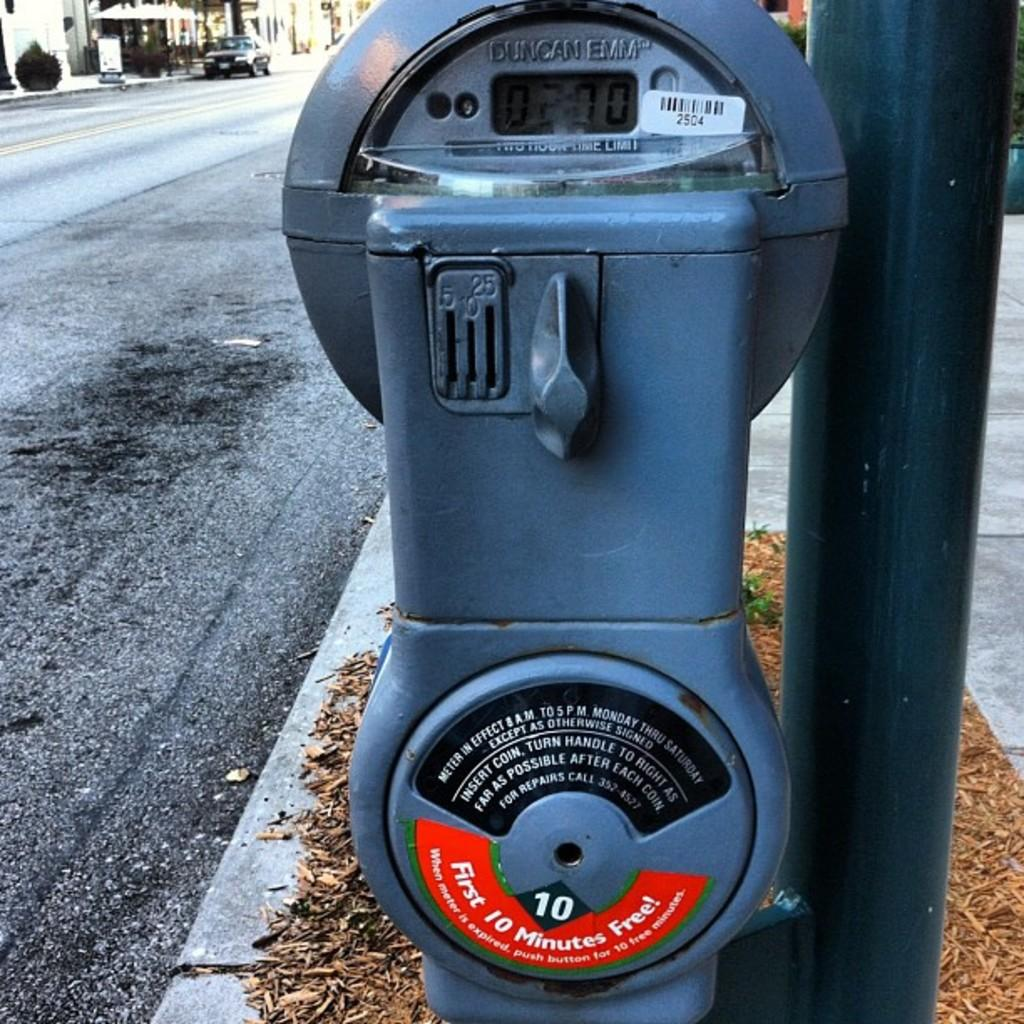Provide a one-sentence caption for the provided image. A Duncan Emm parking meter with a two hour time limit. 